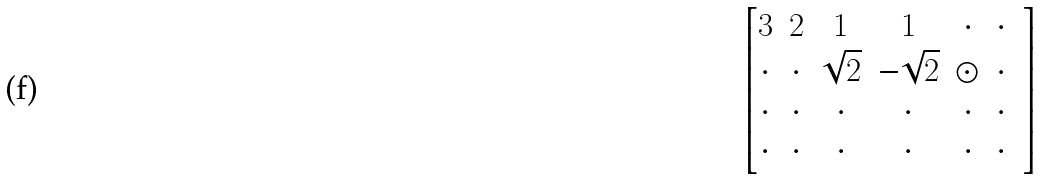<formula> <loc_0><loc_0><loc_500><loc_500>\begin{bmatrix} 3 & 2 & 1 & 1 & \cdot & \cdot \\ \cdot & \cdot & \sqrt { 2 } & - \sqrt { 2 } & \odot & \cdot & \\ \cdot & \cdot & \cdot & \cdot & \cdot & \cdot & \\ \cdot & \cdot & \cdot & \cdot & \cdot & \cdot & \end{bmatrix}</formula> 